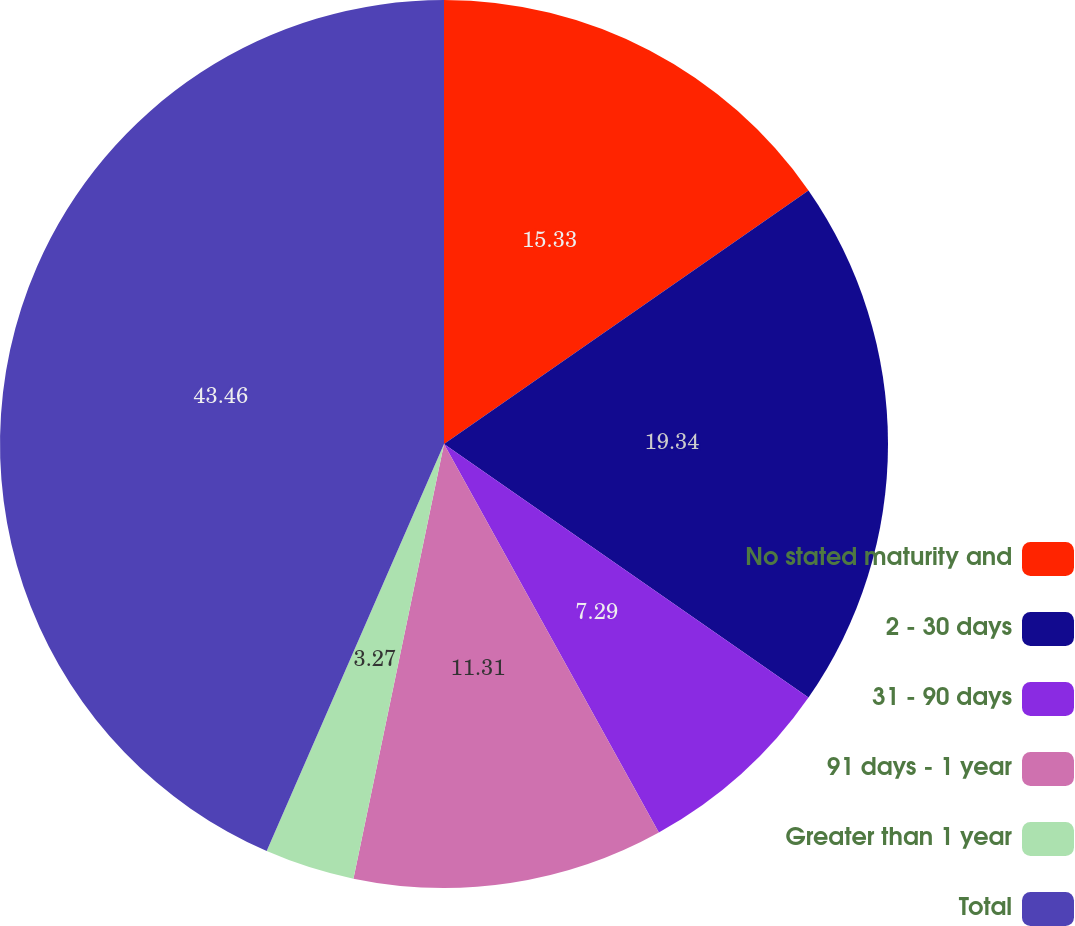Convert chart. <chart><loc_0><loc_0><loc_500><loc_500><pie_chart><fcel>No stated maturity and<fcel>2 - 30 days<fcel>31 - 90 days<fcel>91 days - 1 year<fcel>Greater than 1 year<fcel>Total<nl><fcel>15.33%<fcel>19.35%<fcel>7.29%<fcel>11.31%<fcel>3.27%<fcel>43.47%<nl></chart> 